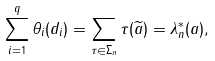<formula> <loc_0><loc_0><loc_500><loc_500>\sum _ { i = 1 } ^ { q } \theta _ { i } ( d _ { i } ) = \sum _ { \tau \in \Sigma _ { n } } \tau ( \widetilde { a } ) = \lambda _ { n } ^ { * } ( a ) ,</formula> 